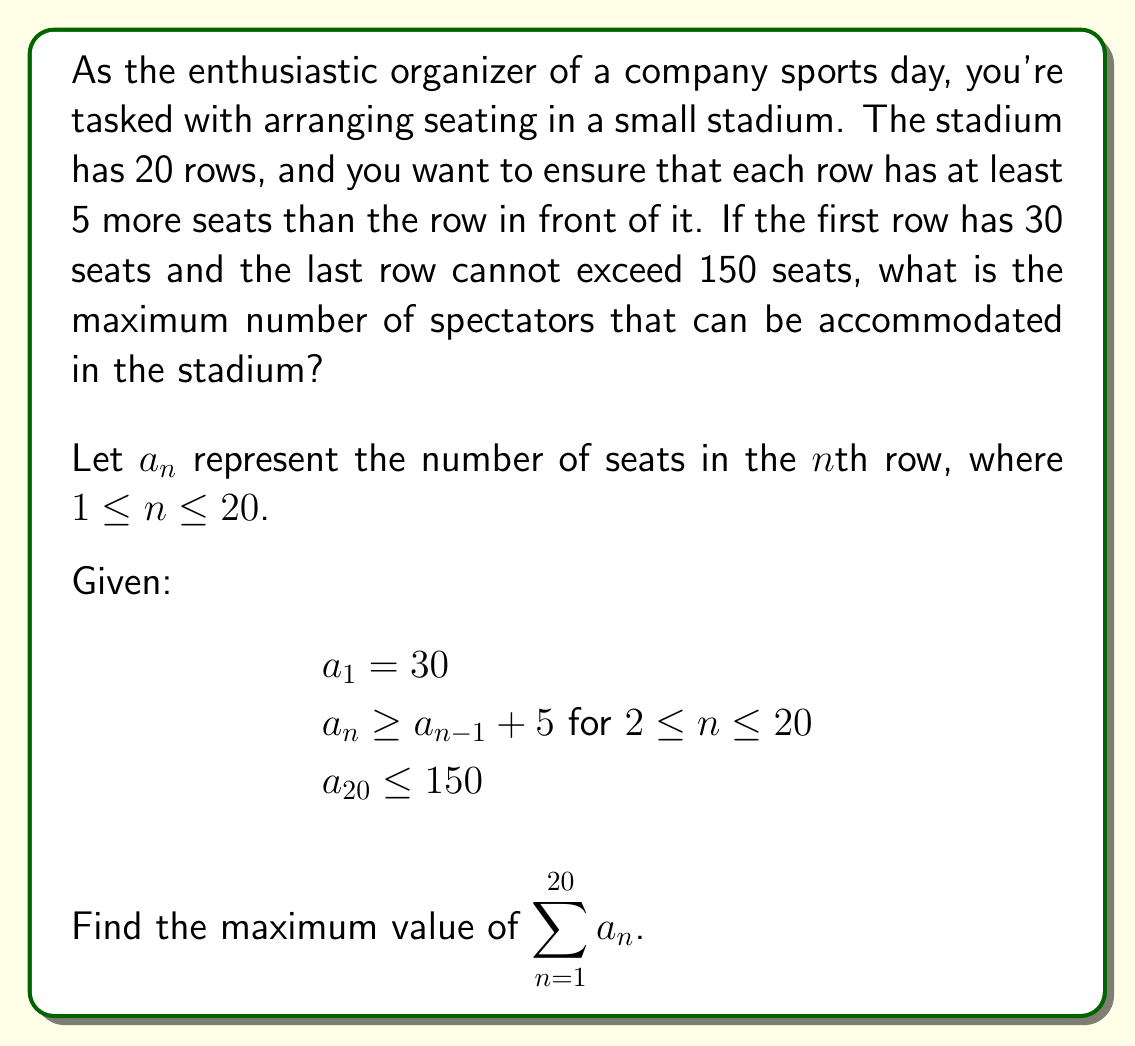Show me your answer to this math problem. To solve this problem, we need to use the concept of arithmetic sequences and inequalities. Let's approach this step-by-step:

1) Given the conditions, we can see that the number of seats in each row forms an arithmetic sequence with a minimum common difference of 5.

2) Let's express the number of seats in each row:
   $a_1 = 30$
   $a_2 \geq 35$
   $a_3 \geq 40$
   ...
   $a_{20} \geq 125$

3) To maximize the total number of seats, we should use the equality in each step:
   $a_n = a_1 + (n-1)d$, where $d = 5$

4) So, the general term of our arithmetic sequence is:
   $a_n = 30 + (n-1)5 = 5n + 25$

5) Now, we need to check if the last term satisfies the given condition:
   $a_{20} = 5(20) + 25 = 125 \leq 150$
   This satisfies the condition, so we can use this sequence.

6) To find the sum of all terms in an arithmetic sequence, we use the formula:
   $S_n = \frac{n}{2}(a_1 + a_n)$, where $n$ is the number of terms

7) In our case:
   $S_{20} = \frac{20}{2}(a_1 + a_{20})$
   $S_{20} = 10(30 + 125)$
   $S_{20} = 10(155) = 1550$

Therefore, the maximum number of spectators that can be accommodated is 1550.
Answer: The maximum number of spectators that can be accommodated in the stadium is 1550. 